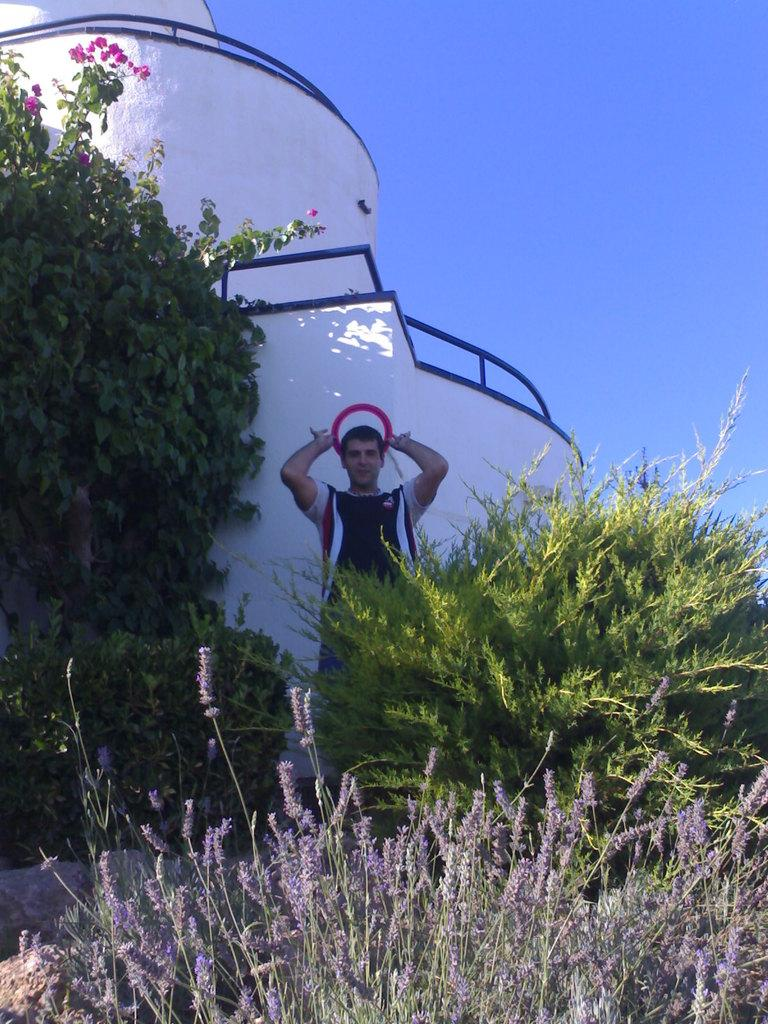What is the main subject of the image? There is a person standing in front of a building in the image. What can be seen in the top right corner of the image? Planets are visible in the top right corner of the image. What is visible in the background of the image? The sky is visible in the image. What type of bean is being used as a support structure in the image? There is no bean or structure made of beans present in the image. 